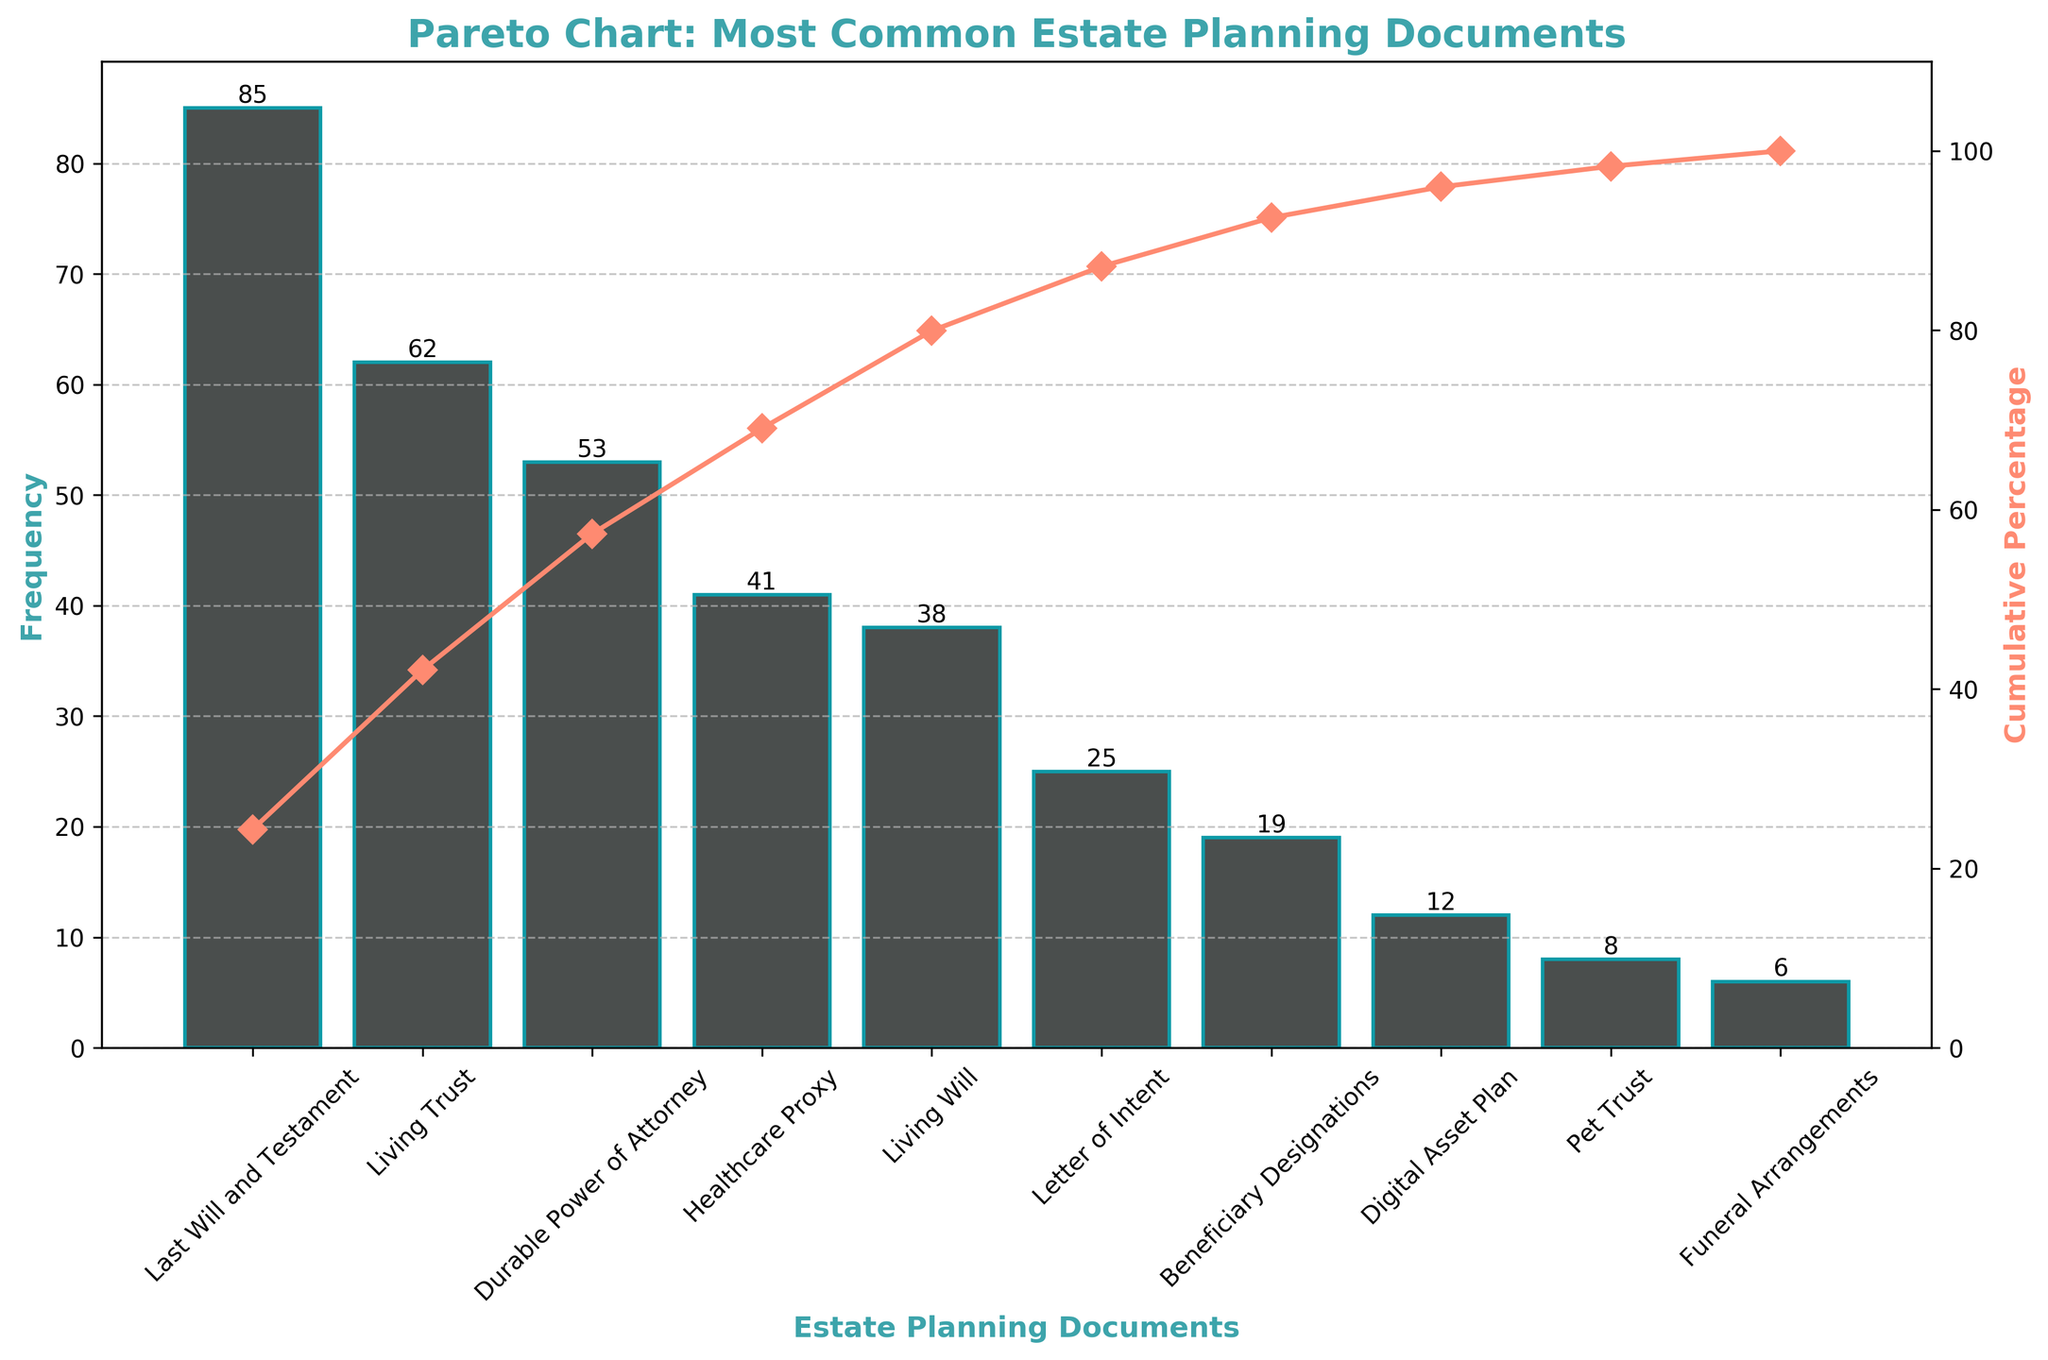What is the title of the figure? The title of the figure is located at the top of the chart and provides a summary of what the chart represents.
Answer: Pareto Chart: Most Common Estate Planning Documents What is the cumulative percentage for 'Healthcare Proxy'? Look for the 'Healthcare Proxy' on the x-axis and refer to the corresponding point on the red line for the cumulative percentage value.
Answer: 81% Which estate planning document has the highest frequency? The height of the bars represents frequency. The tallest bar corresponds to the document with the highest frequency.
Answer: Last Will and Testament How much more frequent is the 'Last Will and Testament' compared to 'Living Trust'? Subtract the frequency of 'Living Trust' from 'Last Will and Testament'.
Answer: 23 What is the combined frequency of 'Durable Power of Attorney' and 'Living Will'? Add the frequencies of 'Durable Power of Attorney' and 'Living Will'.
Answer: 91 Which document has the lowest frequency, and what is its value? Look for the shortest bar and identify the document and its frequency.
Answer: Funeral Arrangements, 6 What is the cumulative percentage after 'Durable Power of Attorney'? Refer to the point on the red line corresponding to 'Durable Power of Attorney' on the x-axis.
Answer: 67% Is the cumulative percentage greater for 'Living Will' or for 'Letter of Intent'? Compare the cumulative percentages of 'Living Will' and 'Letter of Intent' from the red line.
Answer: Living Will How many estate planning documents have a frequency of 25 or higher? Count the number of bars with frequencies at least 25.
Answer: 6 What percentage of the total frequency do 'Pet Trust' and 'Funeral Arrangements' together contribute to? Sum the frequencies of 'Pet Trust' and 'Funeral Arrangements', divide by the total frequency, and multiply by 100 to get the percentage.
Answer: 5.6% 